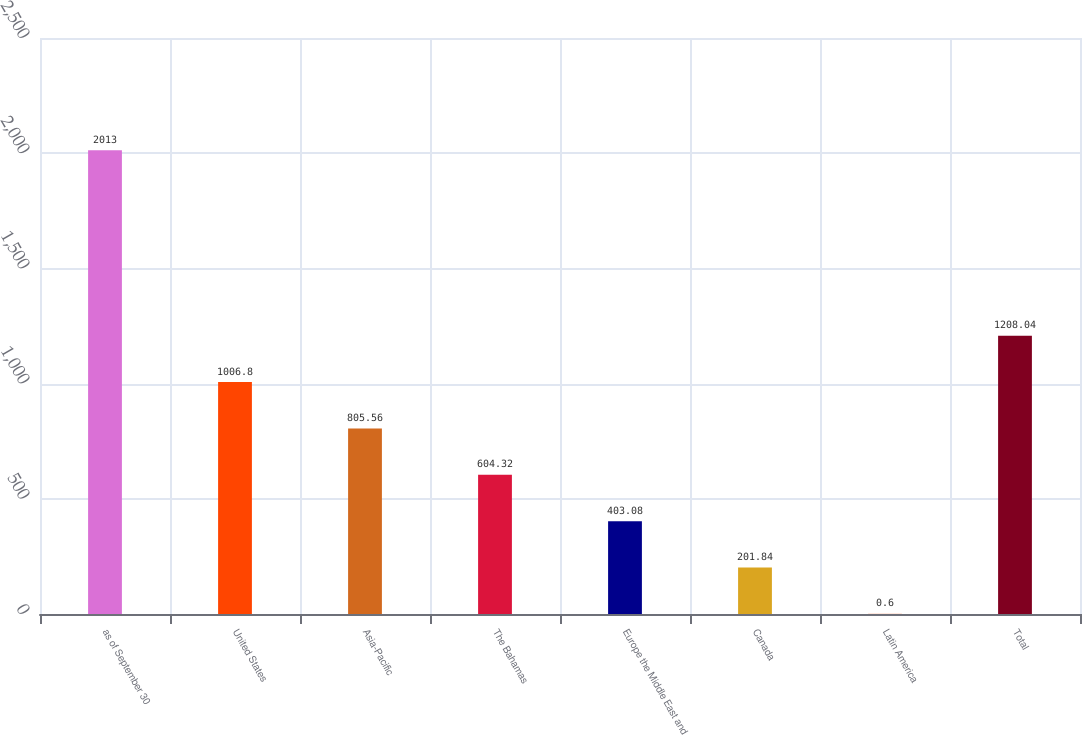Convert chart. <chart><loc_0><loc_0><loc_500><loc_500><bar_chart><fcel>as of September 30<fcel>United States<fcel>Asia-Pacific<fcel>The Bahamas<fcel>Europe the Middle East and<fcel>Canada<fcel>Latin America<fcel>Total<nl><fcel>2013<fcel>1006.8<fcel>805.56<fcel>604.32<fcel>403.08<fcel>201.84<fcel>0.6<fcel>1208.04<nl></chart> 